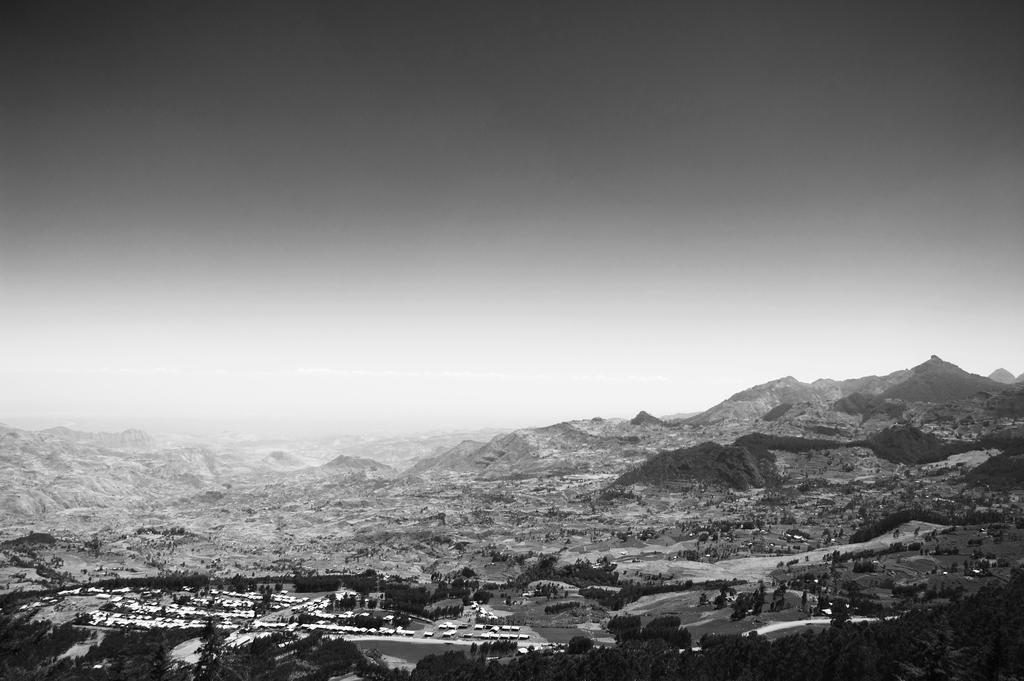How would you summarize this image in a sentence or two? At the bottom of the picture, we see the trees. Behind that, there are many buildings. There are trees and hills in the background. At the top, we see the sky. This is a black and white picture. 